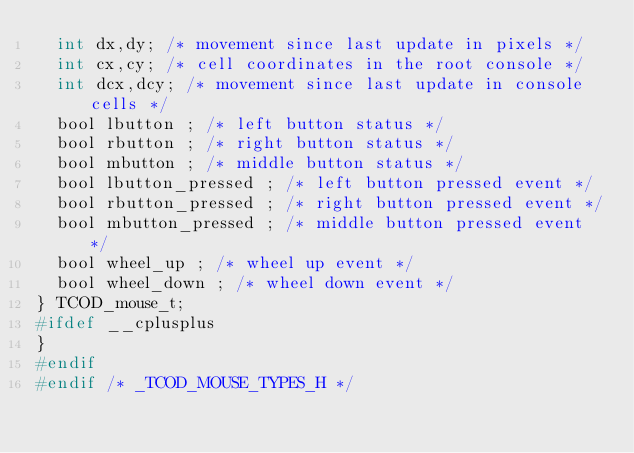<code> <loc_0><loc_0><loc_500><loc_500><_C_>  int dx,dy; /* movement since last update in pixels */
  int cx,cy; /* cell coordinates in the root console */
  int dcx,dcy; /* movement since last update in console cells */
  bool lbutton ; /* left button status */
  bool rbutton ; /* right button status */
  bool mbutton ; /* middle button status */
  bool lbutton_pressed ; /* left button pressed event */ 
  bool rbutton_pressed ; /* right button pressed event */ 
  bool mbutton_pressed ; /* middle button pressed event */ 
  bool wheel_up ; /* wheel up event */
  bool wheel_down ; /* wheel down event */
} TCOD_mouse_t;
#ifdef __cplusplus
}
#endif
#endif /* _TCOD_MOUSE_TYPES_H */
</code> 